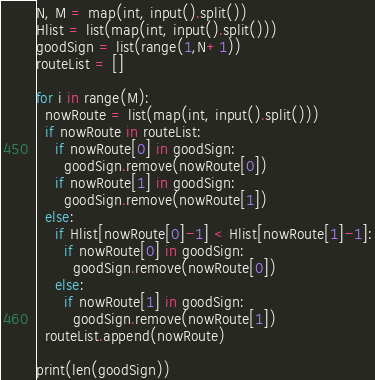Convert code to text. <code><loc_0><loc_0><loc_500><loc_500><_Python_>N, M = map(int, input().split())
Hlist = list(map(int, input().split()))
goodSign = list(range(1,N+1))
routeList = []

for i in range(M):
  nowRoute = list(map(int, input().split()))
  if nowRoute in routeList:
    if nowRoute[0] in goodSign:
      goodSign.remove(nowRoute[0])
    if nowRoute[1] in goodSign:
      goodSign.remove(nowRoute[1])
  else:
    if Hlist[nowRoute[0]-1] < Hlist[nowRoute[1]-1]:
      if nowRoute[0] in goodSign:
        goodSign.remove(nowRoute[0])
    else:
      if nowRoute[1] in goodSign:
        goodSign.remove(nowRoute[1])
  routeList.append(nowRoute)

print(len(goodSign))</code> 